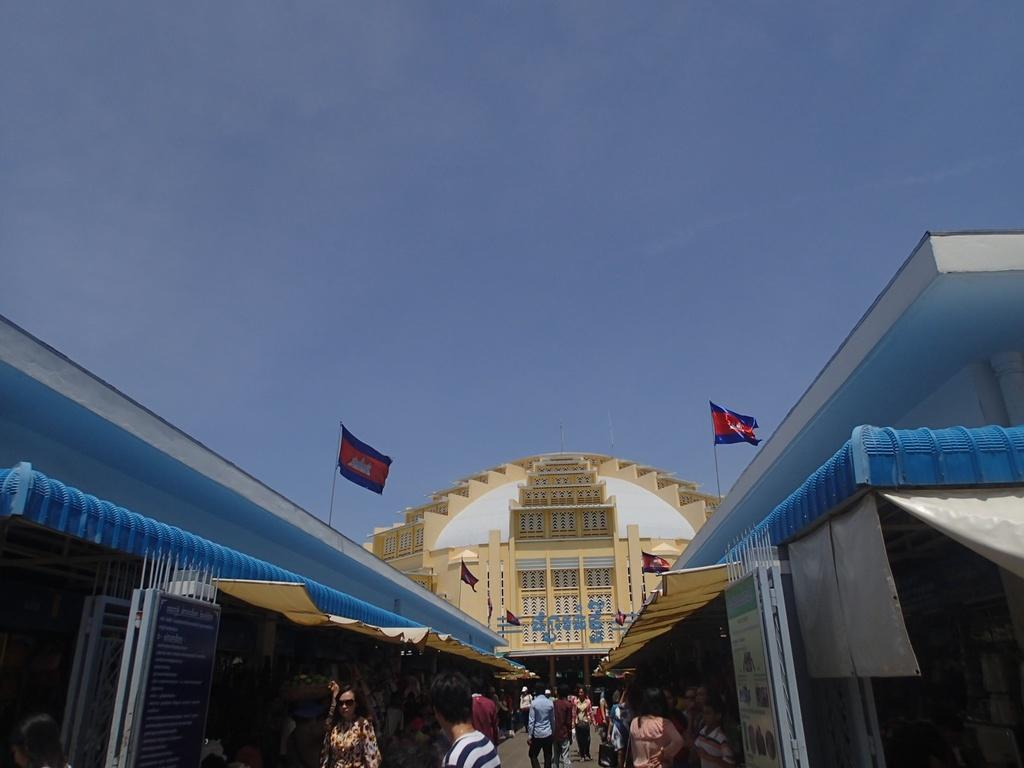What are the people in the image doing? The people in the image are walking on the road. What structure is located in the middle of the image? There is a building in the middle of the image. What can be seen on either side of the building? There are 2 flags on either side of the building. What is visible at the top of the image? The sky is visible at the top of the image. What type of drum can be heard playing in the image? There is no drum present in the image, and therefore no sound can be heard. What is the size of the building in the image? The size of the building cannot be determined from the image alone, as there is no reference point for comparison. 